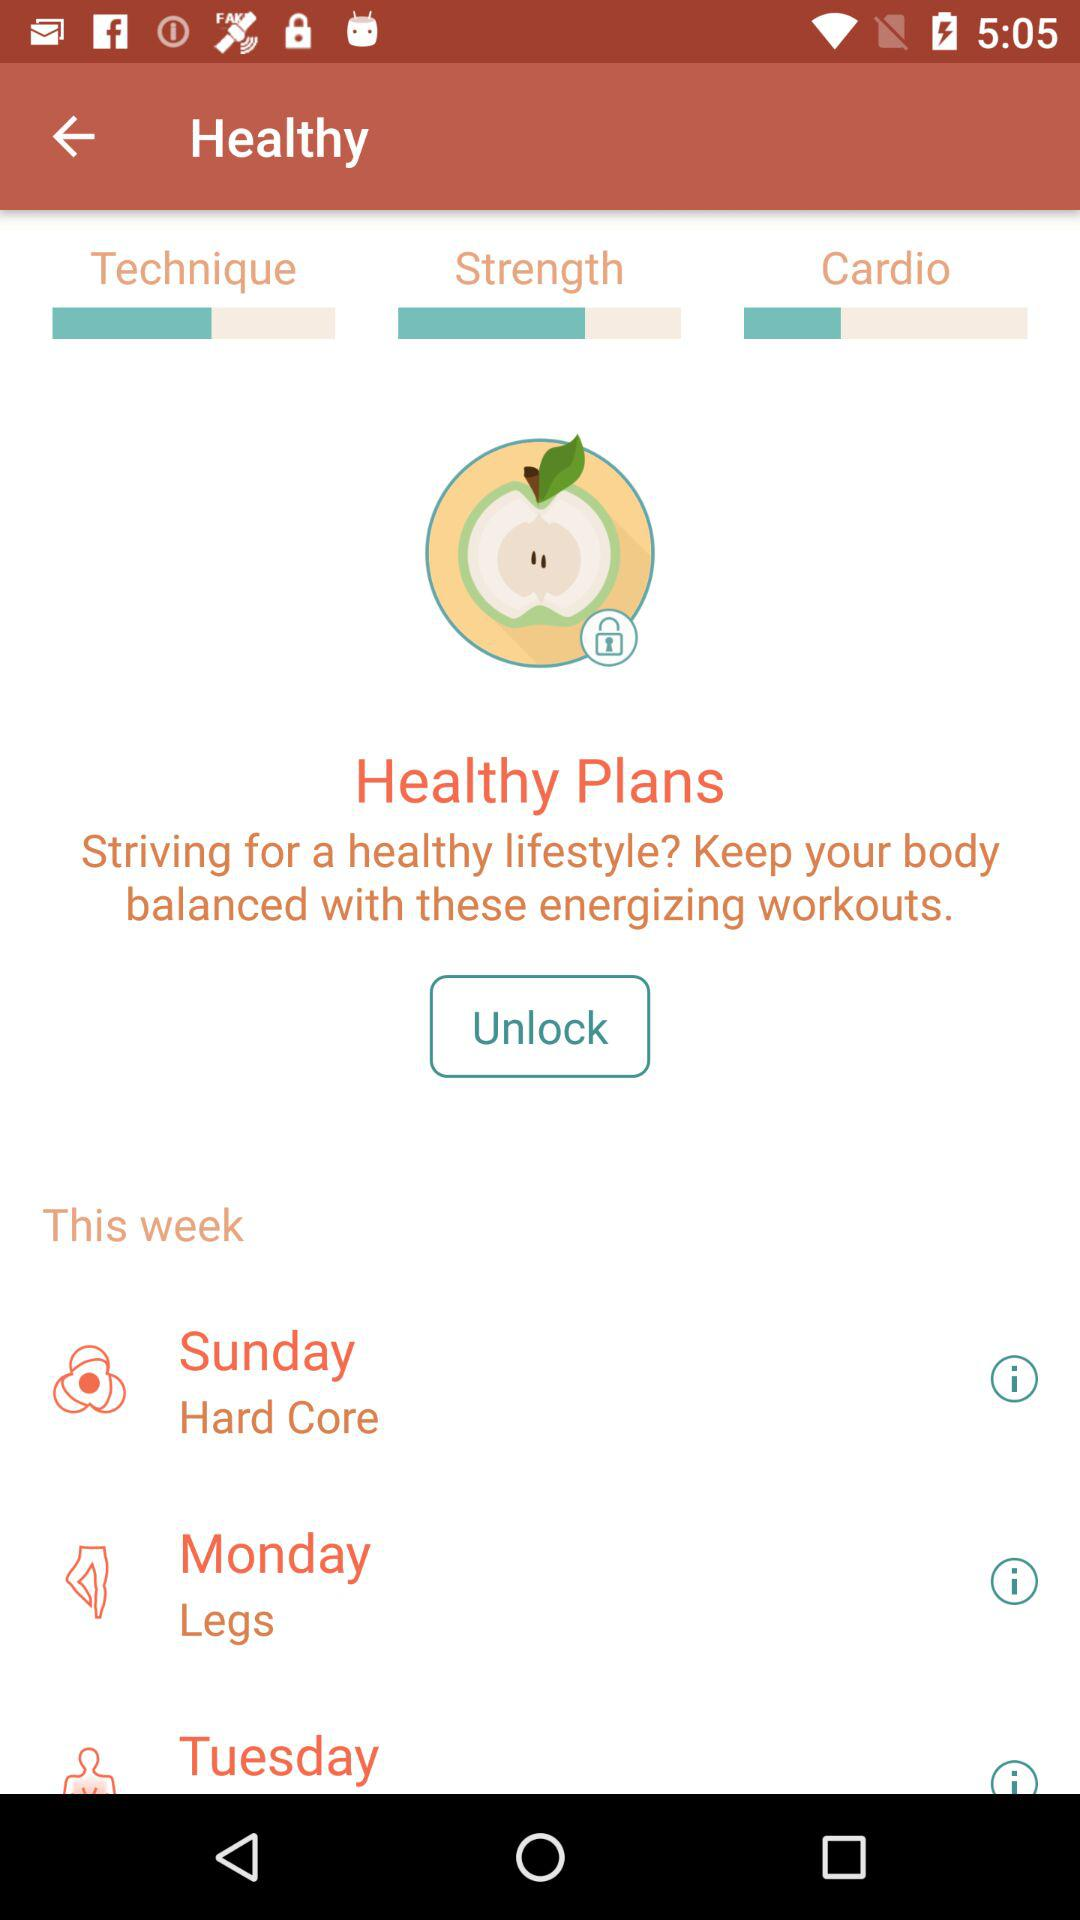How many workouts are there in total?
Answer the question using a single word or phrase. 3 